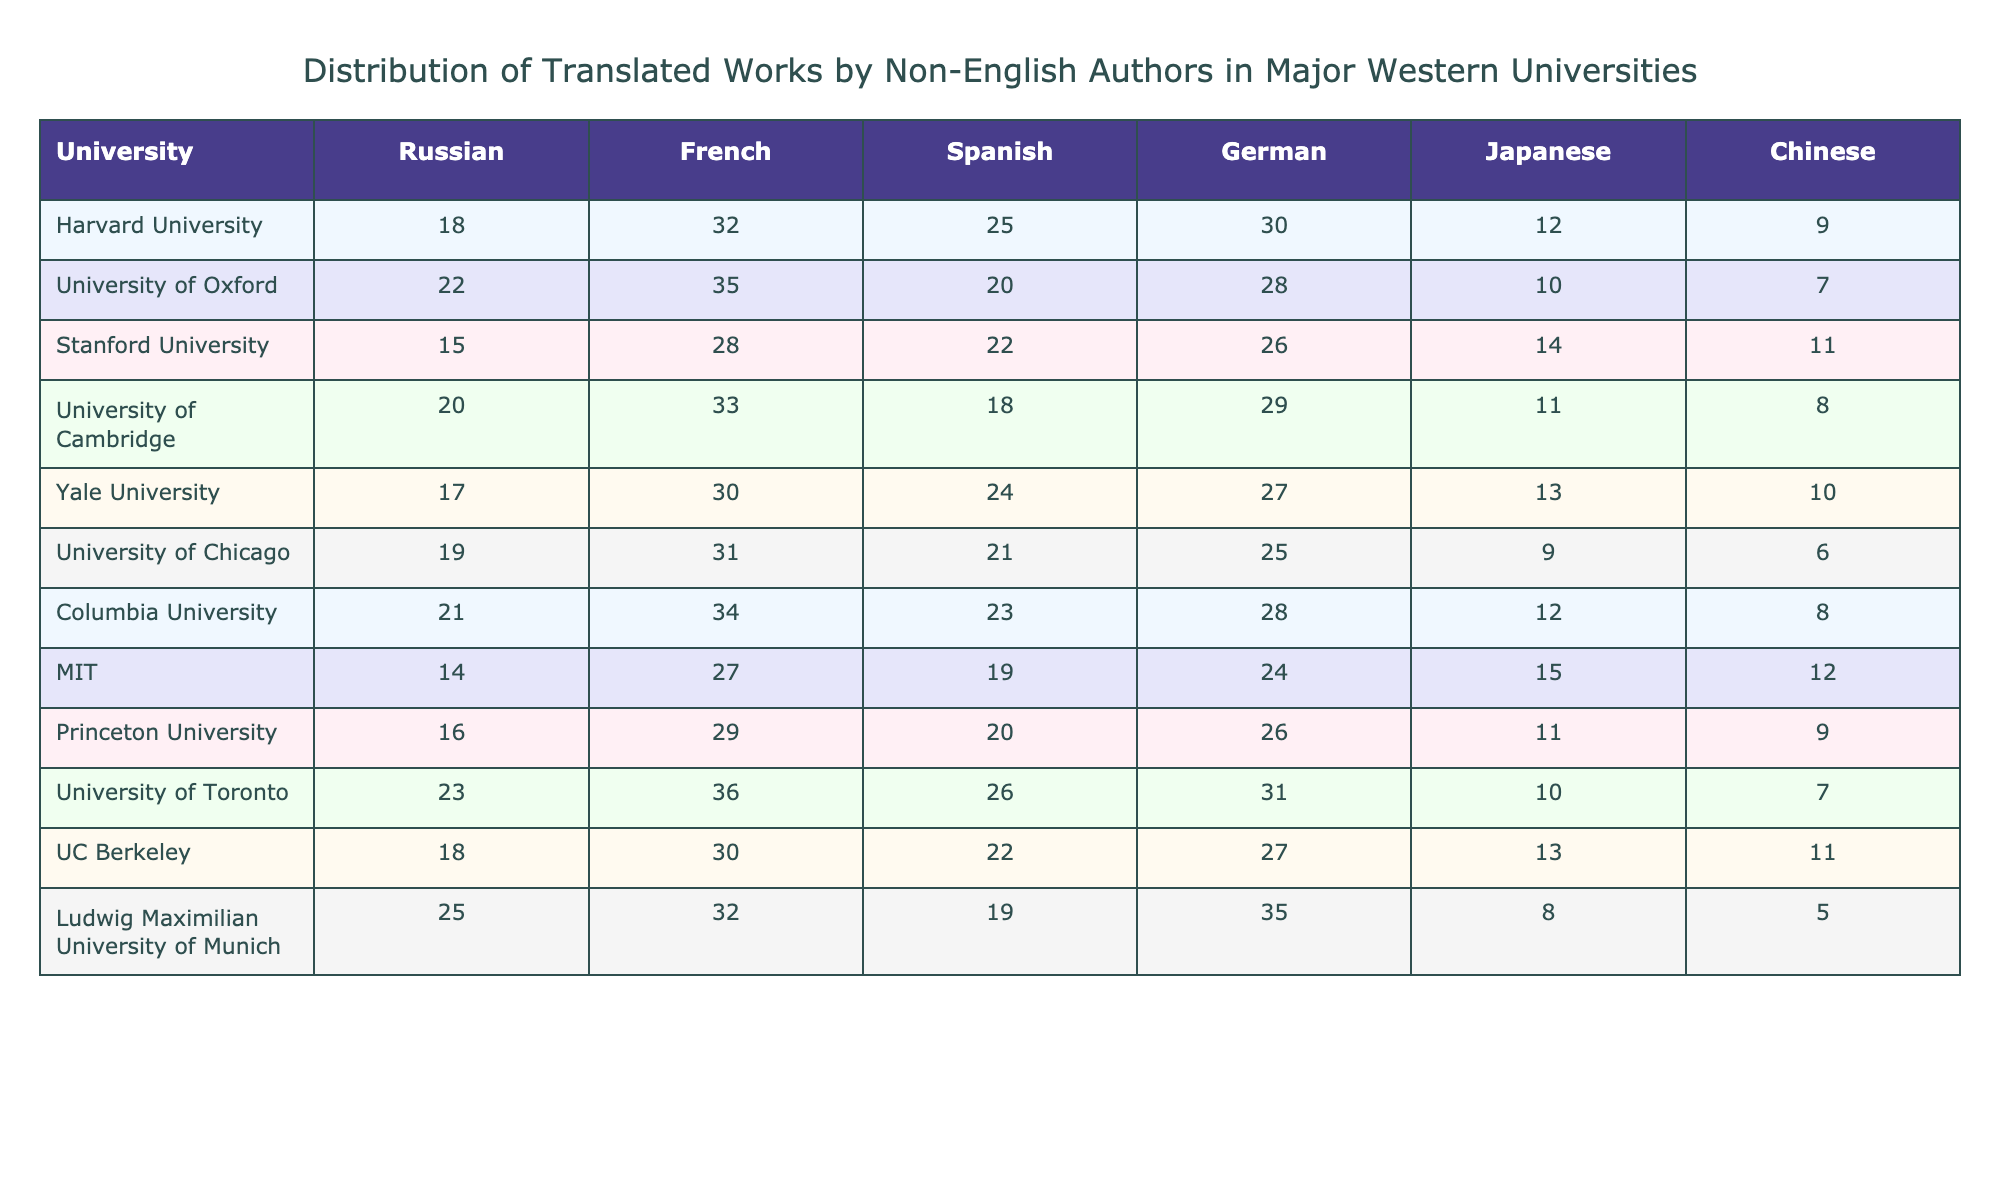What is the highest number of translated works from Russian at a university? The highest number comes from Ludwig Maximilian University of Munich, which has 25 translated works from Russian.
Answer: 25 Which university has the least number of translated works from Japanese? The university with the least Japanese works is Ludwig Maximilian University of Munich, with 8 translated works.
Answer: 8 What is the total number of translated works from French across all universities? Adding the French translations from each university gives us a total of (32 + 35 + 28 + 33 + 30 + 31 + 34 + 27 + 29 + 36 + 30 + 32) = 372.
Answer: 372 Which two universities have the same number of Spanish translated works, and what is that number? Stanford University and MIT both have 22 translated works from Spanish.
Answer: 22 Does Harvard University have more Chinese translated works than University of Toronto? Harvard University has 9 translated works from Chinese, while University of Toronto has 7. So, yes, Harvard University has more.
Answer: Yes What is the average number of German translations across all listed universities? The sum of the German translations is (30 + 28 + 26 + 29 + 27 + 25 + 28 + 24 + 26 + 31 + 27 + 35) =  322. There are 12 universities, so the average is 322/12 ≈ 26.83.
Answer: 26.83 Which university has the most translated works from Spanish and how many? University of Toronto has the most Spanish works with a total of 26.
Answer: 26 If we compare the Russian translations between Princeton University and UC Berkeley, which has more and by how much? Princeton University has 16 Russian translations, while UC Berkeley has 18. Therefore, UC Berkeley has 2 more Russian translations.
Answer: 2 more What is the range of Japanese translated works among these universities? The maximum is 15 (MIT) and the minimum is 8 (Ludwig Maximilian University of Munich), so the range is 15 - 8 = 7.
Answer: 7 Is the total number of translated works from all languages at Yale University greater than that of University of Cambridge? Yale University has 30 + 24 + 27 + 13 + 10 = 104, while University of Cambridge has 33 + 18 + 29 + 11 + 8 = 99. So, yes, Yale University has more.
Answer: Yes What percentage of translated works from Chinese does Stanford University represent in relation to the total Chinese translations across all universities? The total Chinese translations are 9 + 7 + 11 + 8 + 10 + 6 + 8 + 12 + 9 + 7 + 11 + 5 = 109. Stanford has 11, so the percentage is (11/109) * 100 ≈ 10.09%.
Answer: 10.09% 